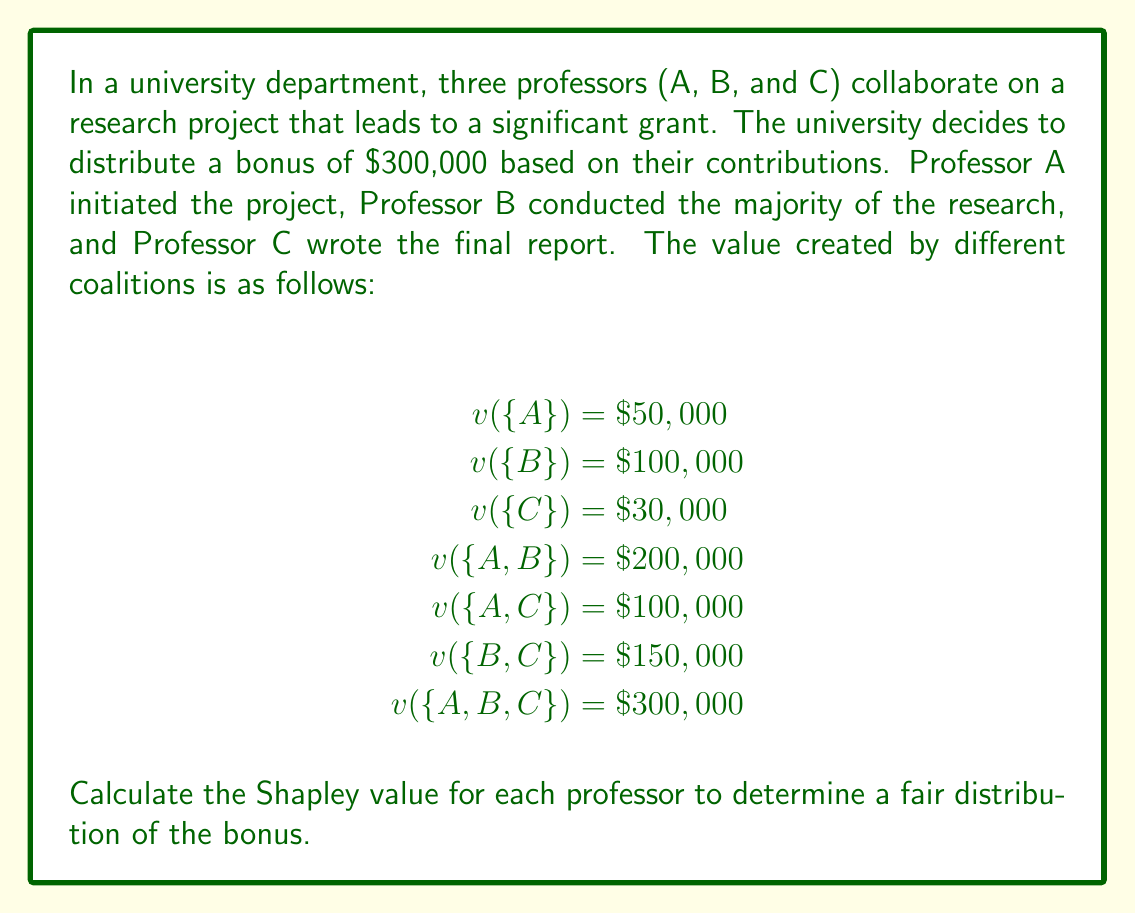Solve this math problem. To calculate the Shapley value for each professor, we need to follow these steps:

1. List all possible orderings of the professors:
   ABC, ACB, BAC, BCA, CAB, CBA

2. For each ordering, calculate the marginal contribution of each professor:

ABC: A: 50,000  B: 150,000  C: 100,000
ACB: A: 50,000  C: 50,000   B: 200,000
BAC: B: 100,000 A: 100,000  C: 100,000
BCA: B: 100,000 C: 50,000   A: 150,000
CAB: C: 30,000  A: 70,000   B: 200,000
CBA: C: 30,000  B: 120,000  A: 150,000

3. Calculate the average marginal contribution for each professor:

Professor A:
$\phi_A = \frac{1}{6}(50,000 + 50,000 + 100,000 + 150,000 + 70,000 + 150,000) = \$95,000$

Professor B:
$\phi_B = \frac{1}{6}(150,000 + 200,000 + 100,000 + 100,000 + 200,000 + 120,000) = \$145,000$

Professor C:
$\phi_C = \frac{1}{6}(100,000 + 50,000 + 100,000 + 50,000 + 30,000 + 30,000) = \$60,000$

4. Verify that the sum of Shapley values equals the total value:
$\phi_A + \phi_B + \phi_C = 95,000 + 145,000 + 60,000 = 300,000$

The Shapley value provides a fair distribution of the bonus based on each professor's average marginal contribution to the project.
Answer: The Shapley values for the fair distribution of the $300,000 bonus are:

Professor A: $\$95,000$
Professor B: $\$145,000$
Professor C: $\$60,000$ 